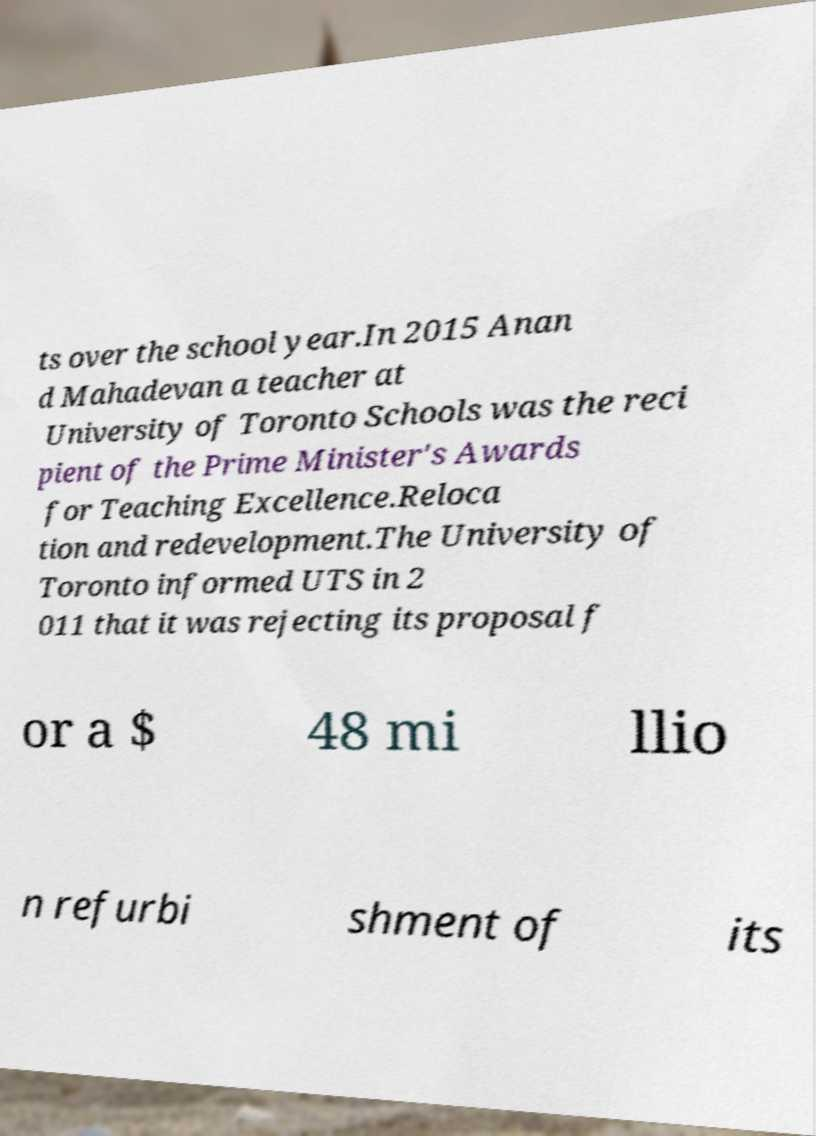Please read and relay the text visible in this image. What does it say? ts over the school year.In 2015 Anan d Mahadevan a teacher at University of Toronto Schools was the reci pient of the Prime Minister's Awards for Teaching Excellence.Reloca tion and redevelopment.The University of Toronto informed UTS in 2 011 that it was rejecting its proposal f or a $ 48 mi llio n refurbi shment of its 